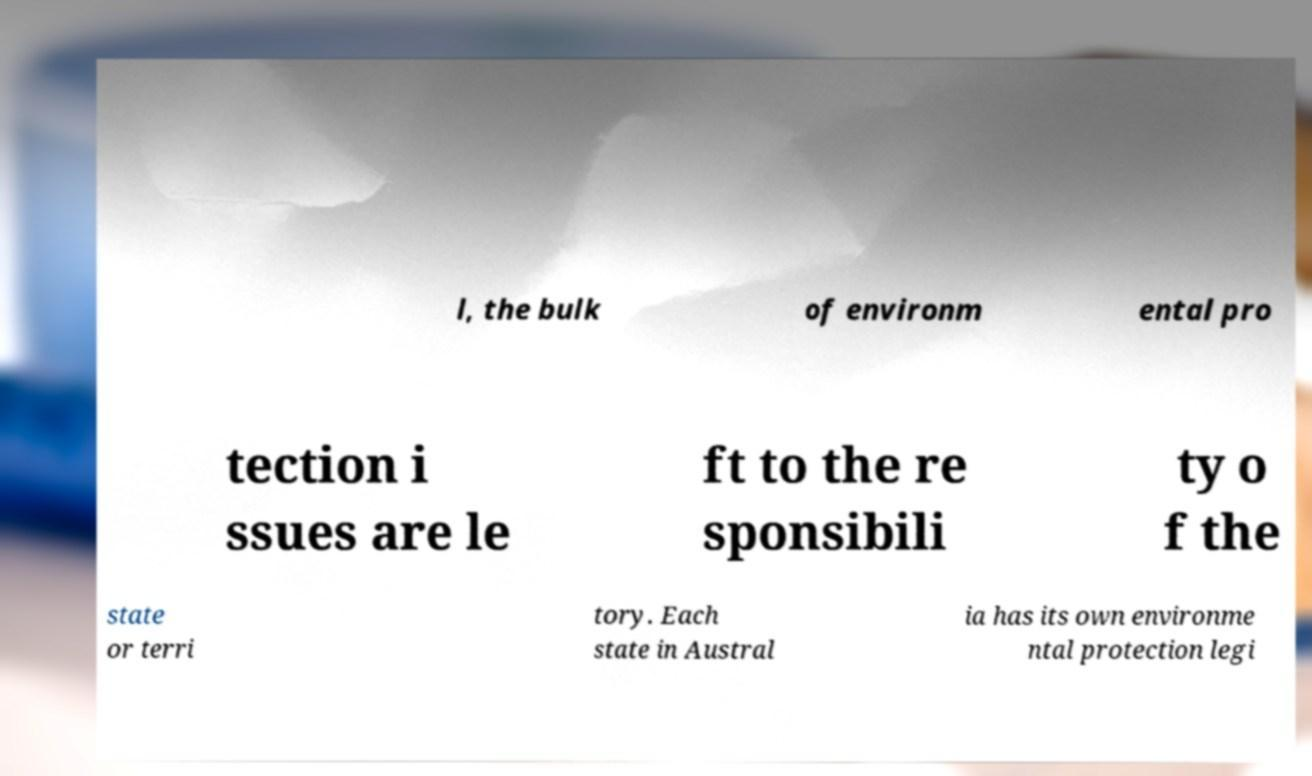Could you assist in decoding the text presented in this image and type it out clearly? l, the bulk of environm ental pro tection i ssues are le ft to the re sponsibili ty o f the state or terri tory. Each state in Austral ia has its own environme ntal protection legi 